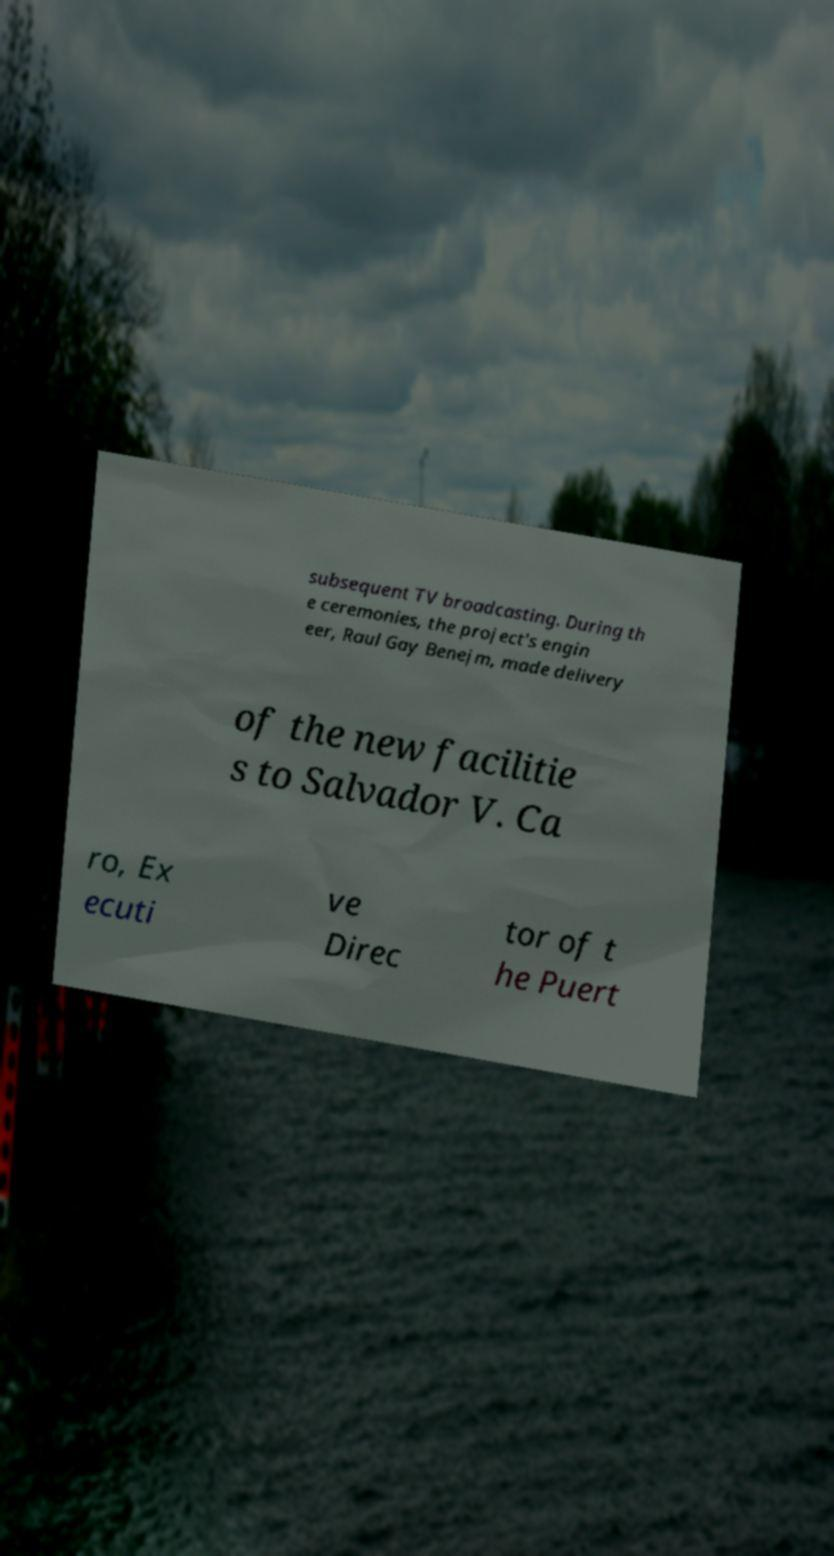For documentation purposes, I need the text within this image transcribed. Could you provide that? subsequent TV broadcasting. During th e ceremonies, the project's engin eer, Raul Gay Benejm, made delivery of the new facilitie s to Salvador V. Ca ro, Ex ecuti ve Direc tor of t he Puert 